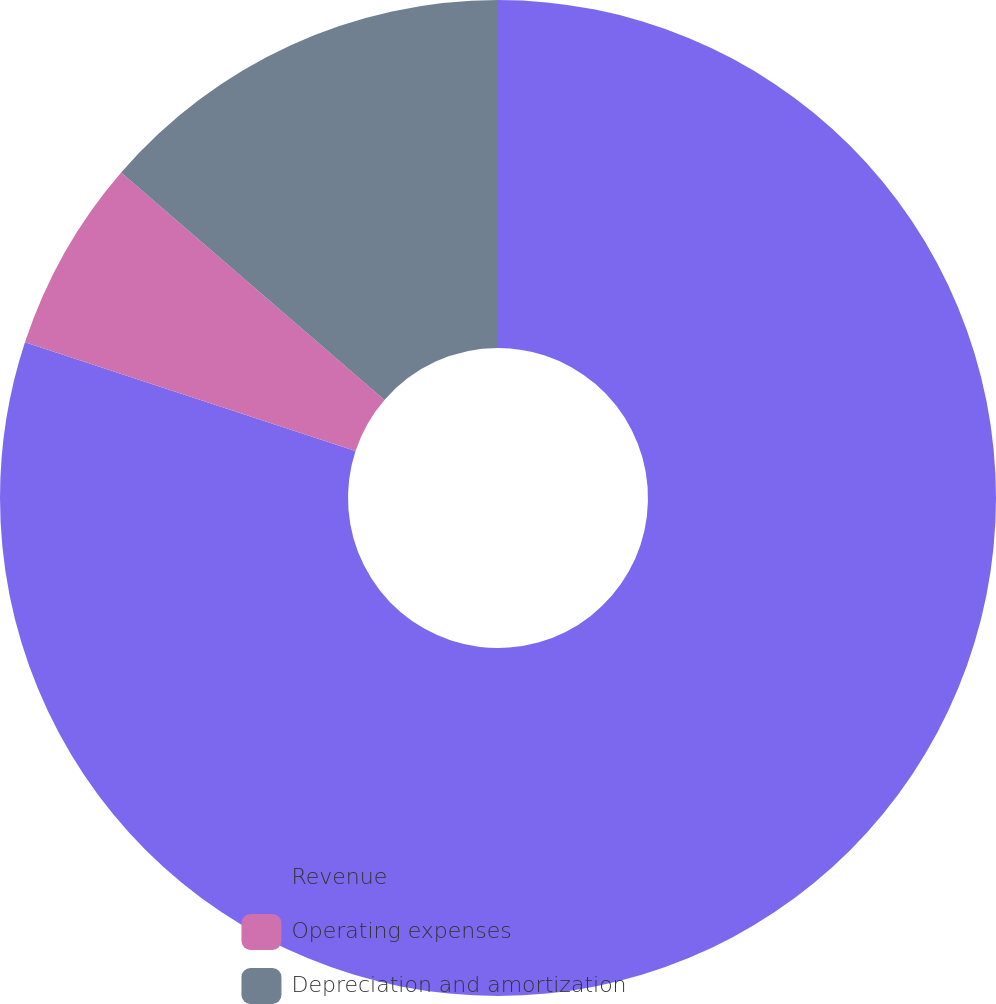Convert chart. <chart><loc_0><loc_0><loc_500><loc_500><pie_chart><fcel>Revenue<fcel>Operating expenses<fcel>Depreciation and amortization<nl><fcel>80.06%<fcel>6.28%<fcel>13.66%<nl></chart> 